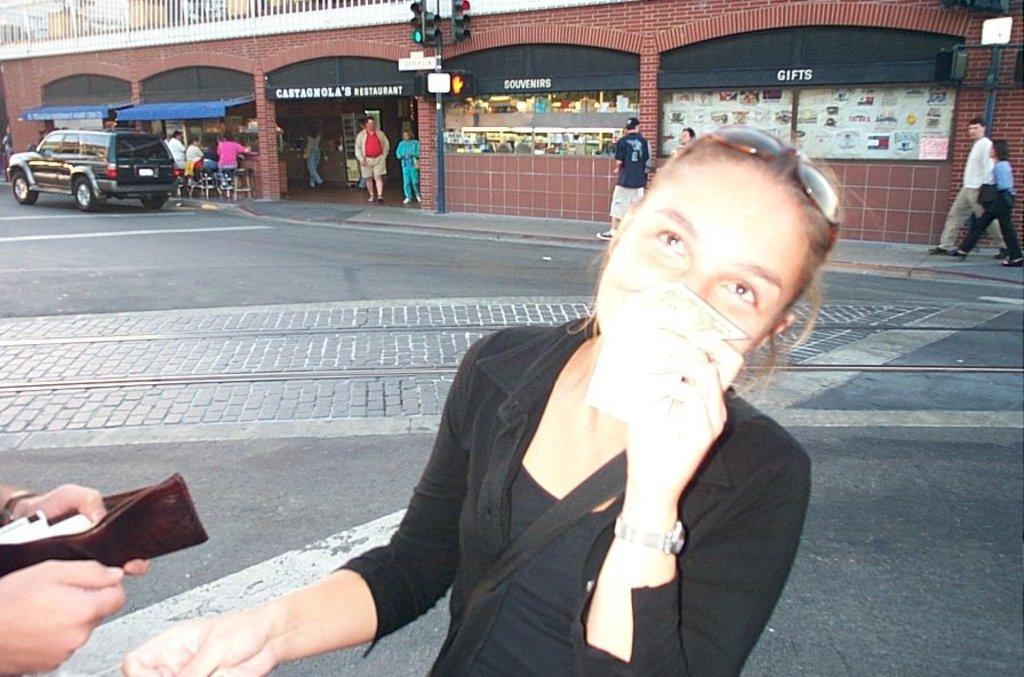Can you describe this image briefly? In the image we can see there are many people, standing, walking and sitting. This is a money wallet, wrist watch, goggle, signal pole, building, vehicle, road and number plate of the vehicle, this is a fencing. 